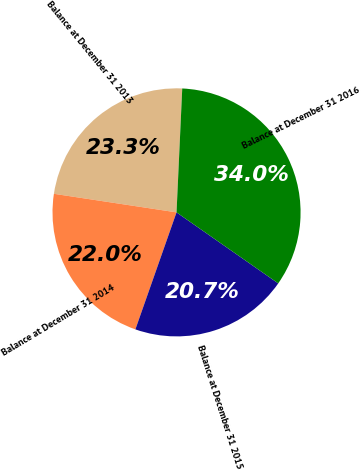Convert chart to OTSL. <chart><loc_0><loc_0><loc_500><loc_500><pie_chart><fcel>Balance at December 31 2013<fcel>Balance at December 31 2014<fcel>Balance at December 31 2015<fcel>Balance at December 31 2016<nl><fcel>23.34%<fcel>22.01%<fcel>20.68%<fcel>33.97%<nl></chart> 